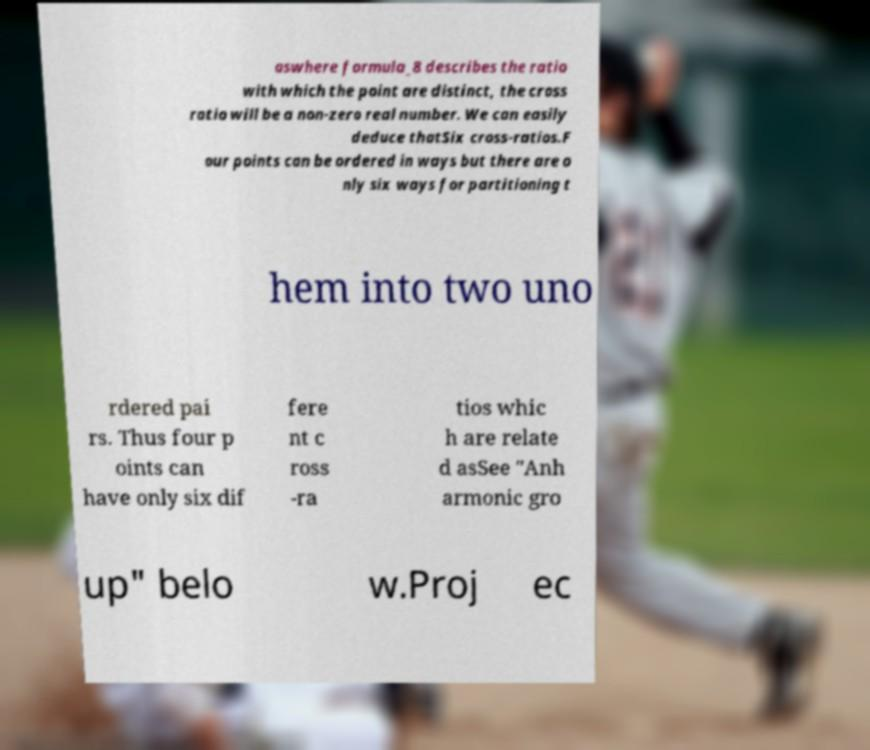I need the written content from this picture converted into text. Can you do that? aswhere formula_8 describes the ratio with which the point are distinct, the cross ratio will be a non-zero real number. We can easily deduce thatSix cross-ratios.F our points can be ordered in ways but there are o nly six ways for partitioning t hem into two uno rdered pai rs. Thus four p oints can have only six dif fere nt c ross -ra tios whic h are relate d asSee "Anh armonic gro up" belo w.Proj ec 